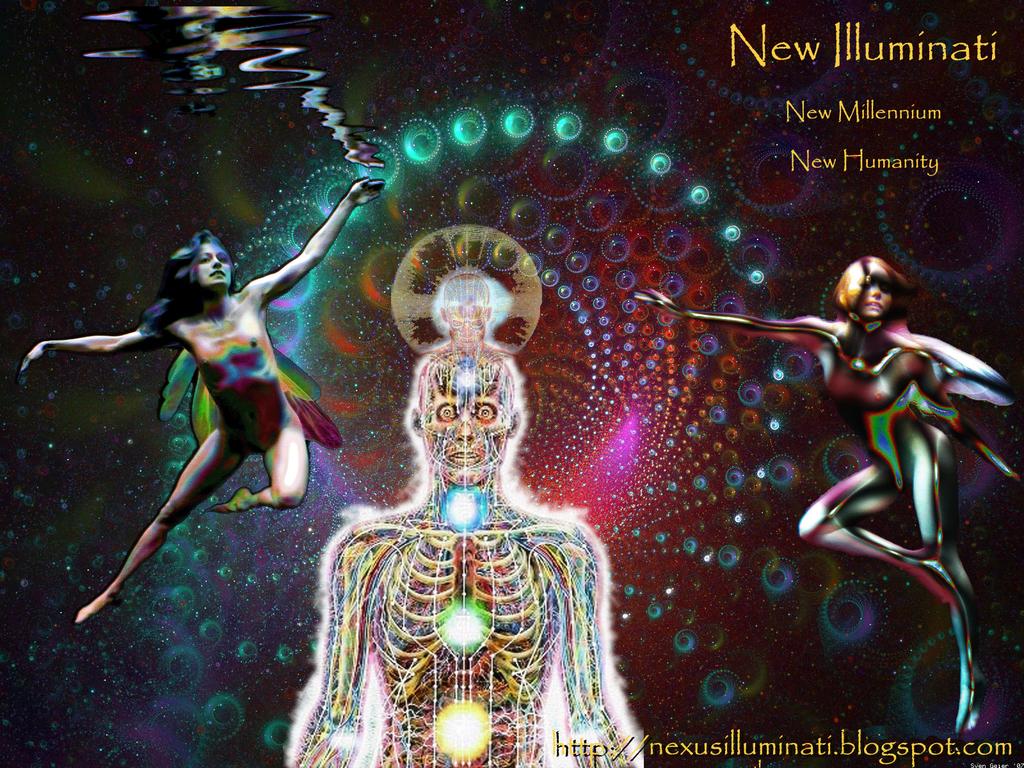Which website is this image for?
Offer a terse response. Http://nexusilluminati.blogspot.com. What is the link shown?
Ensure brevity in your answer.  Http://nexusilluminati.blogspot.com. 